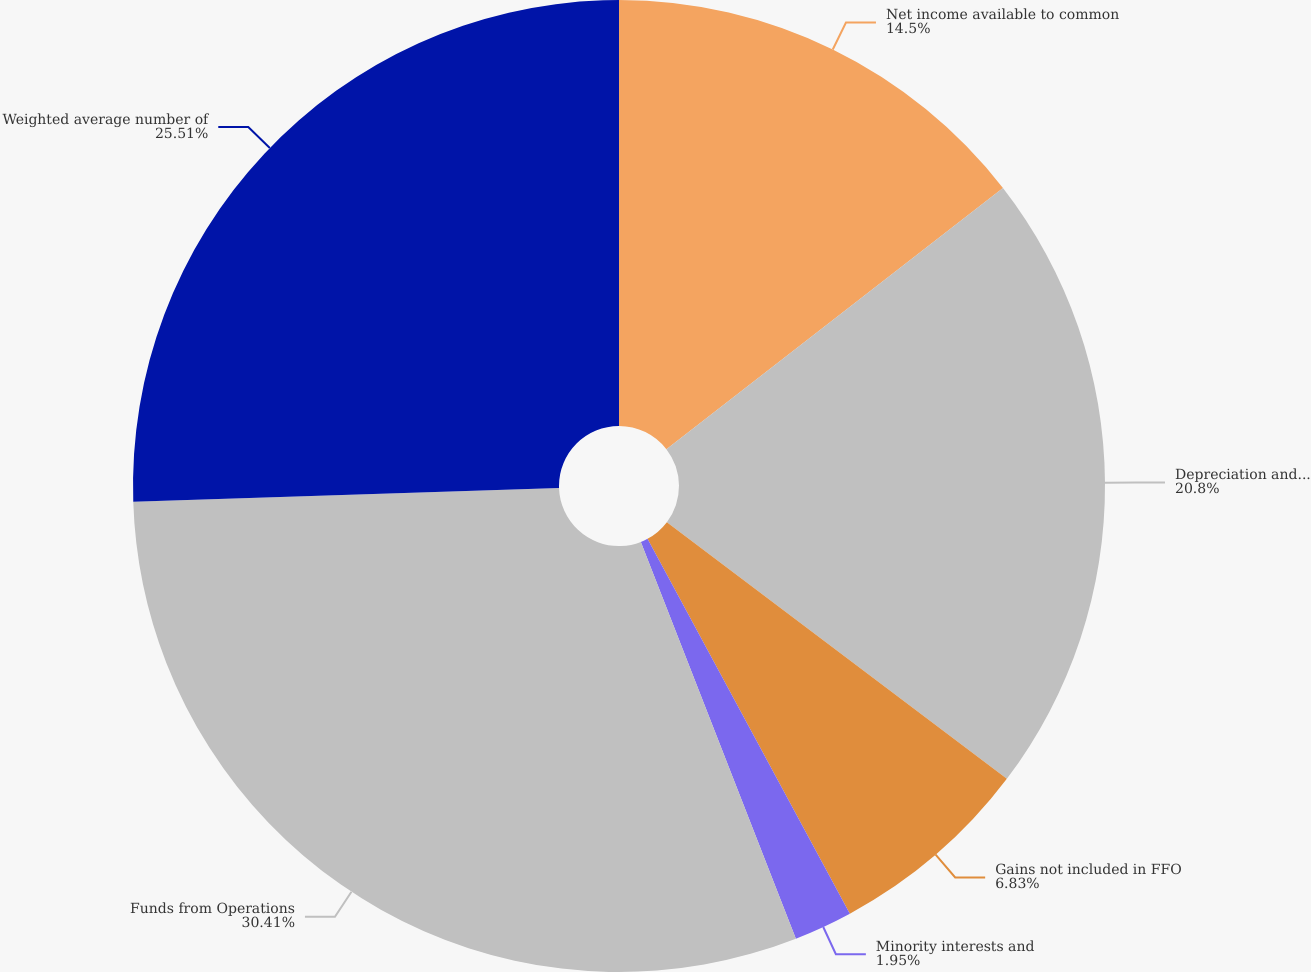Convert chart. <chart><loc_0><loc_0><loc_500><loc_500><pie_chart><fcel>Net income available to common<fcel>Depreciation and amortization<fcel>Gains not included in FFO<fcel>Minority interests and<fcel>Funds from Operations<fcel>Weighted average number of<nl><fcel>14.5%<fcel>20.8%<fcel>6.83%<fcel>1.95%<fcel>30.42%<fcel>25.52%<nl></chart> 